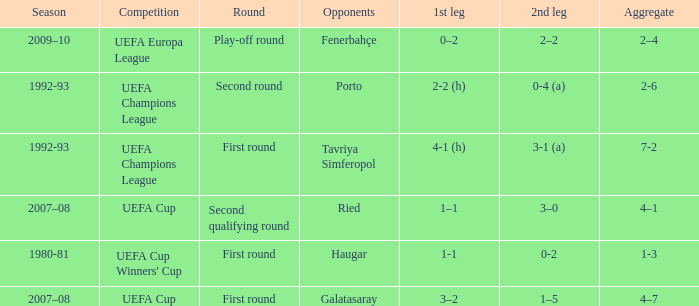What is the total number of 2nd leg where aggregate is 7-2 1.0. 